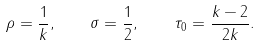Convert formula to latex. <formula><loc_0><loc_0><loc_500><loc_500>\rho = \frac { 1 } { k } , \quad \sigma = \frac { 1 } { 2 } , \quad \tau _ { 0 } = \frac { k - 2 } { 2 k } .</formula> 